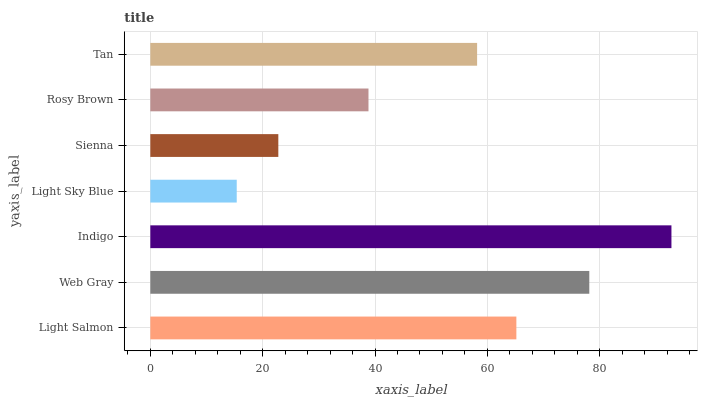Is Light Sky Blue the minimum?
Answer yes or no. Yes. Is Indigo the maximum?
Answer yes or no. Yes. Is Web Gray the minimum?
Answer yes or no. No. Is Web Gray the maximum?
Answer yes or no. No. Is Web Gray greater than Light Salmon?
Answer yes or no. Yes. Is Light Salmon less than Web Gray?
Answer yes or no. Yes. Is Light Salmon greater than Web Gray?
Answer yes or no. No. Is Web Gray less than Light Salmon?
Answer yes or no. No. Is Tan the high median?
Answer yes or no. Yes. Is Tan the low median?
Answer yes or no. Yes. Is Sienna the high median?
Answer yes or no. No. Is Sienna the low median?
Answer yes or no. No. 